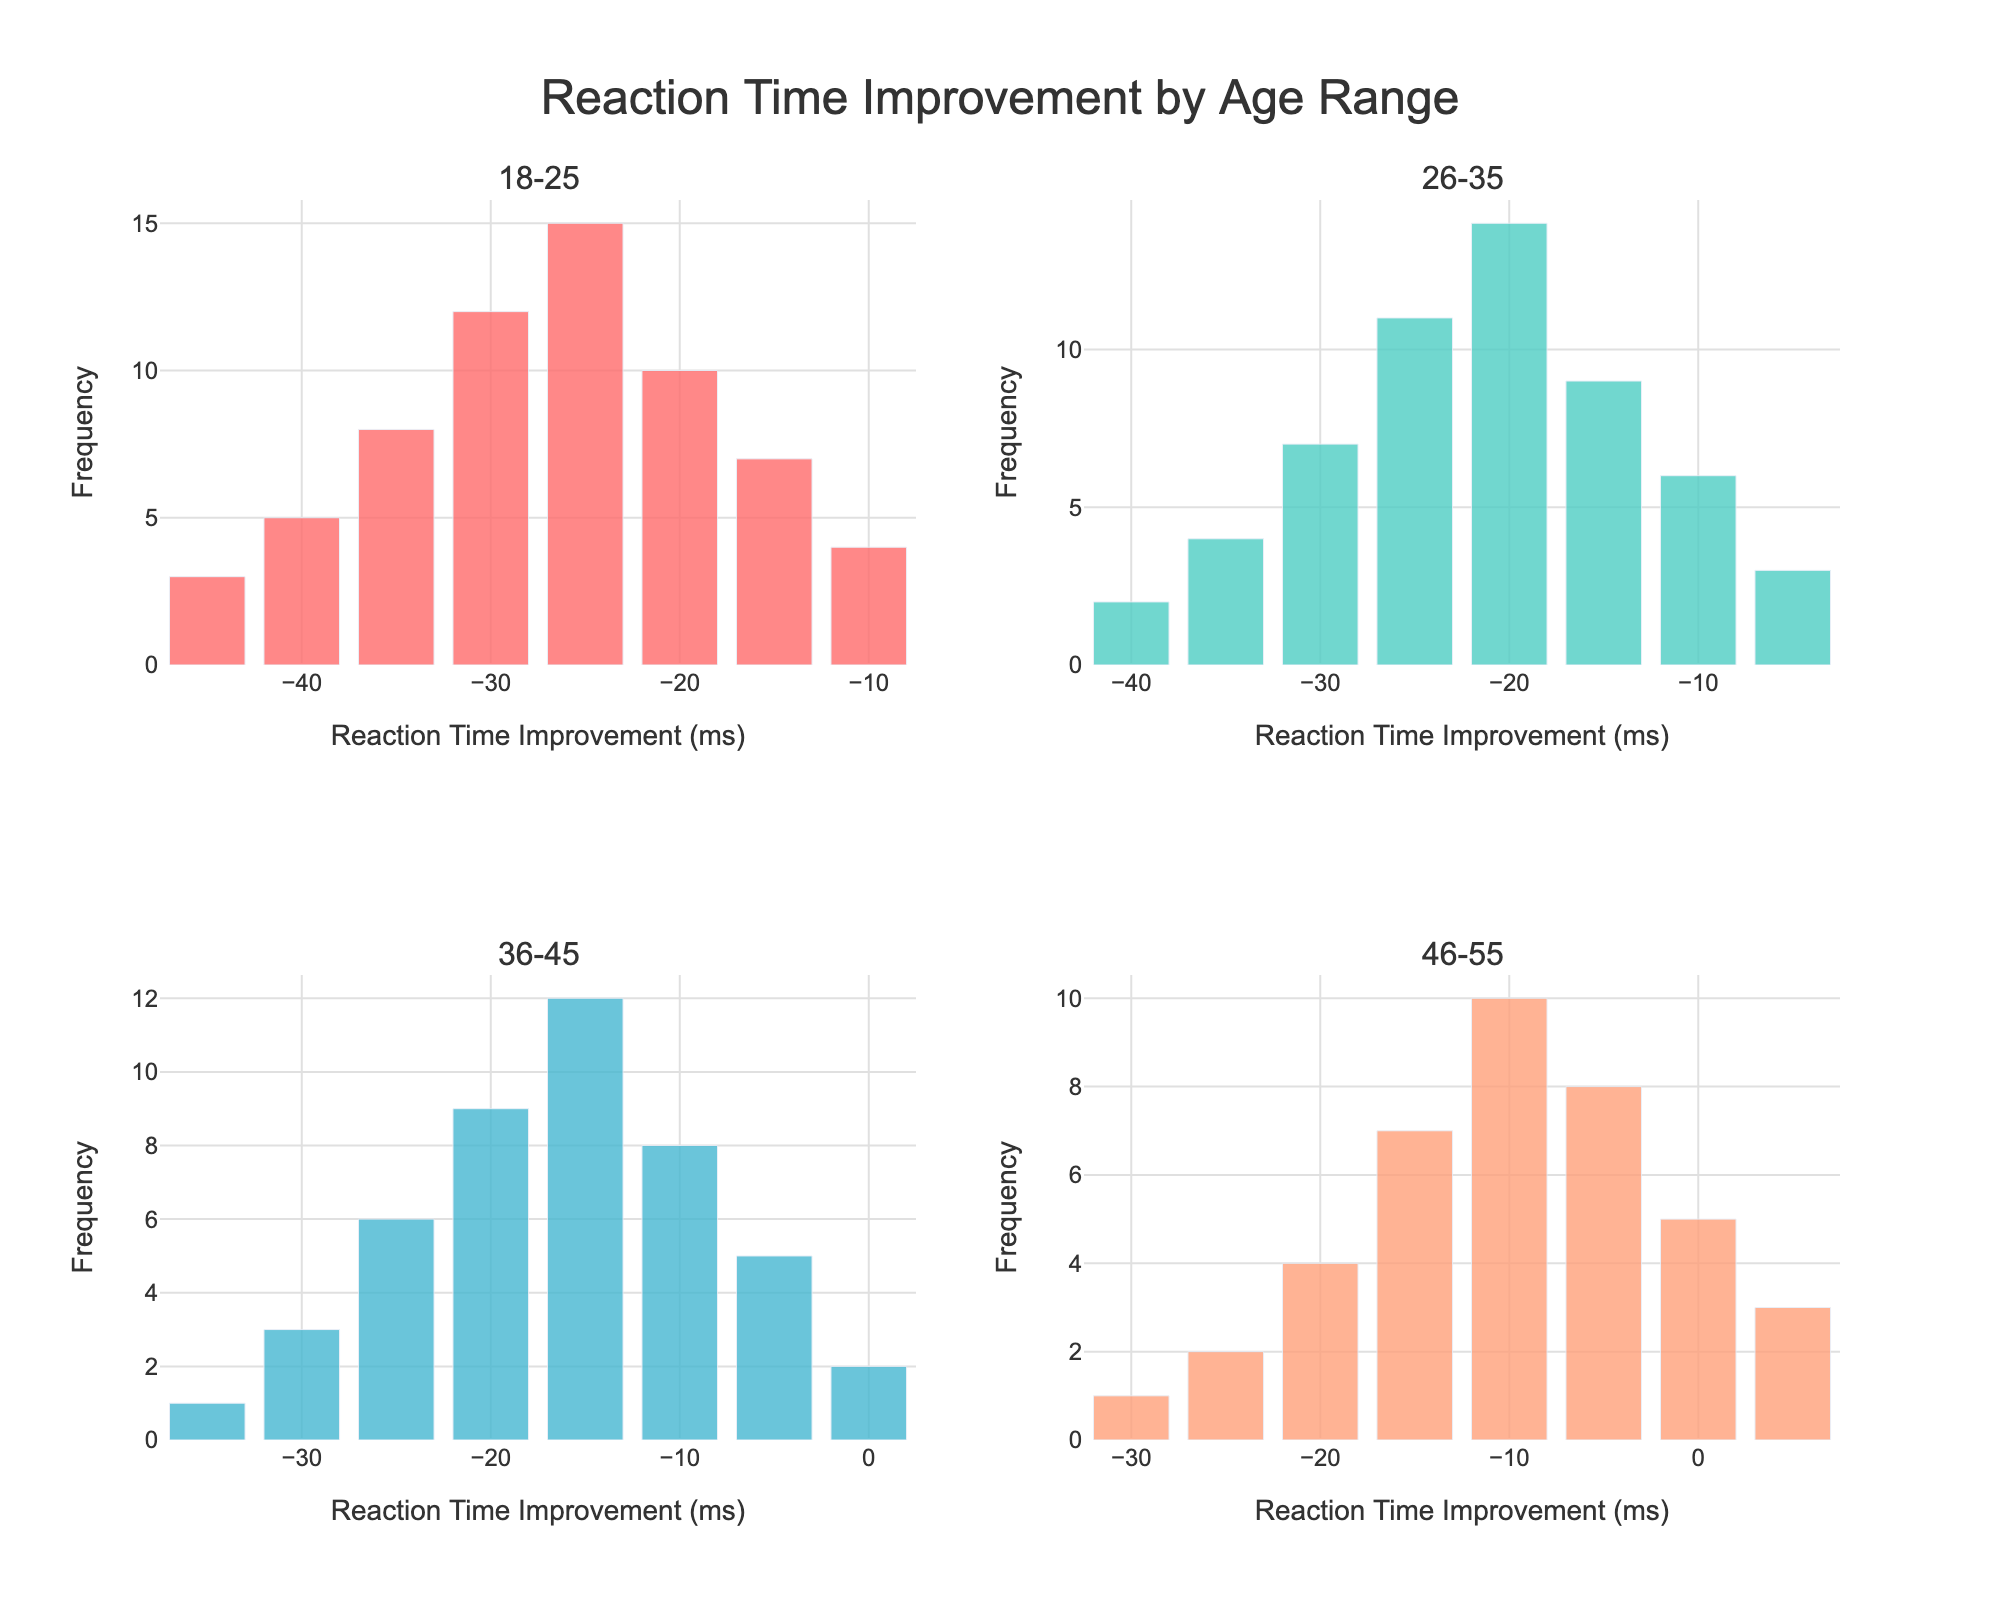What are the age ranges represented in the subplots? In the subplot titles, there are four distinct age ranges shown: 18-25, 26-35, 36-45, and 46-55. Each subplot title indicates an age range.
Answer: 18-25, 26-35, 36-45, 46-55 What is the title of the whole figure? The title of the figure is prominently displayed at the top center of the figure. It reads "Reaction Time Improvement by Age Range."
Answer: Reaction Time Improvement by Age Range Which age range has the largest frequency for any single reaction time improvement category? By examining the subplots, the largest frequency for any single category can be observed in the 18-25 age range. The highest bar shows a frequency of 15 for the -25 ms improvement.
Answer: 18-25 What is the reaction time improvement category with the highest frequency in the 36-45 age range? In the 36-45 age range subplot, the category with the highest bar corresponds to a reaction time improvement of -15 ms, with a frequency of 12.
Answer: -15 ms Compare the median reaction time improvement between the 18-25 and 26-35 age ranges. The median value is the middle value when ordered. In the 18-25 range, the most centered value around the frequency peak is -25 ms. For the 26-35 range, the value around the frequency peak is -20 ms. So, the 18-25 range has a lower median improvement.
Answer: -25 ms (18-25), -20 ms (26-35) Which age group shows both negative and positive reaction time improvements? In their subplot, the 46-55 age range shows bars extending into both negative and positive reaction time improvements, with -30 ms to +5 ms being shown.
Answer: 46-55 How does the frequency of the -20 ms category compare across the age ranges? In the -20 ms category, the frequencies are 10 (18-25), 14 (26-35), 9 (36-45), and 4 (46-55). The 26-35 range has the highest frequency, and 46-55 has the lowest.
Answer: 10 (18-25), 14 (26-35), 9 (36-45), 4 (46-55) What is the general trend in reaction time improvement as age increases? Generally, younger age ranges (18-25 and 26-35) have higher frequencies in larger negative reaction time improvements, indicating more significant improvements. Older ranges (46-55) have smaller improvements and even some positive values, indicating less improvement.
Answer: Younger show larger improvements, older show smaller or positive Which age range has the smallest improvement category visible? The 46-55 age range shows improvements reaching positive values, with the smallest improvement category visible being +5 ms.
Answer: 46-55 Determine the range of reaction time improvements shown in the 36-45 age range. The reaction time improvements in the 36-45 age range go from -35 ms to 0 ms.
Answer: -35 ms to 0 ms 